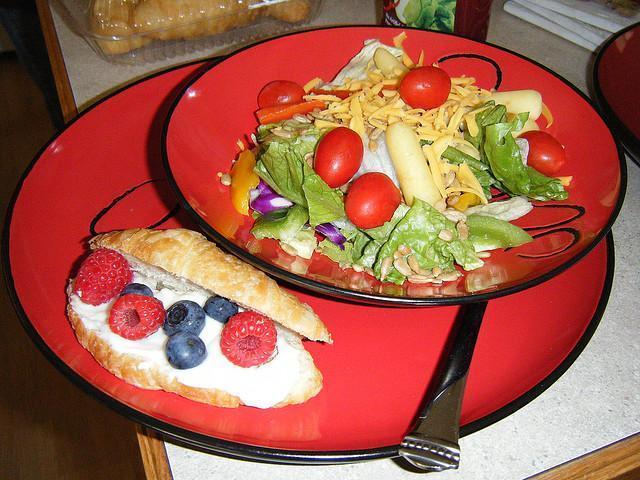How many red vases are in the picture?
Give a very brief answer. 0. 